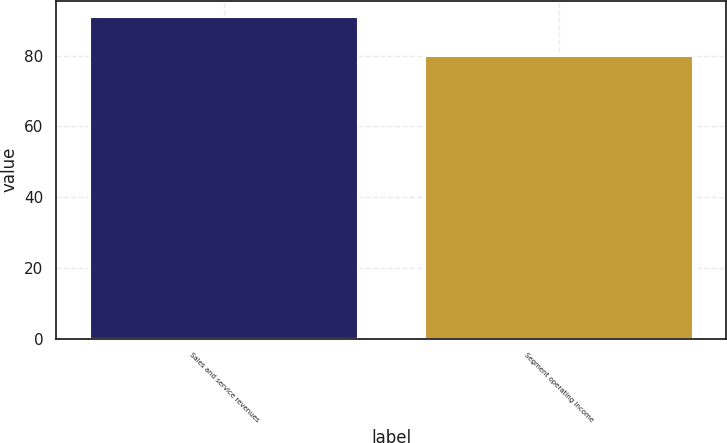<chart> <loc_0><loc_0><loc_500><loc_500><bar_chart><fcel>Sales and service revenues<fcel>Segment operating income<nl><fcel>91<fcel>80<nl></chart> 